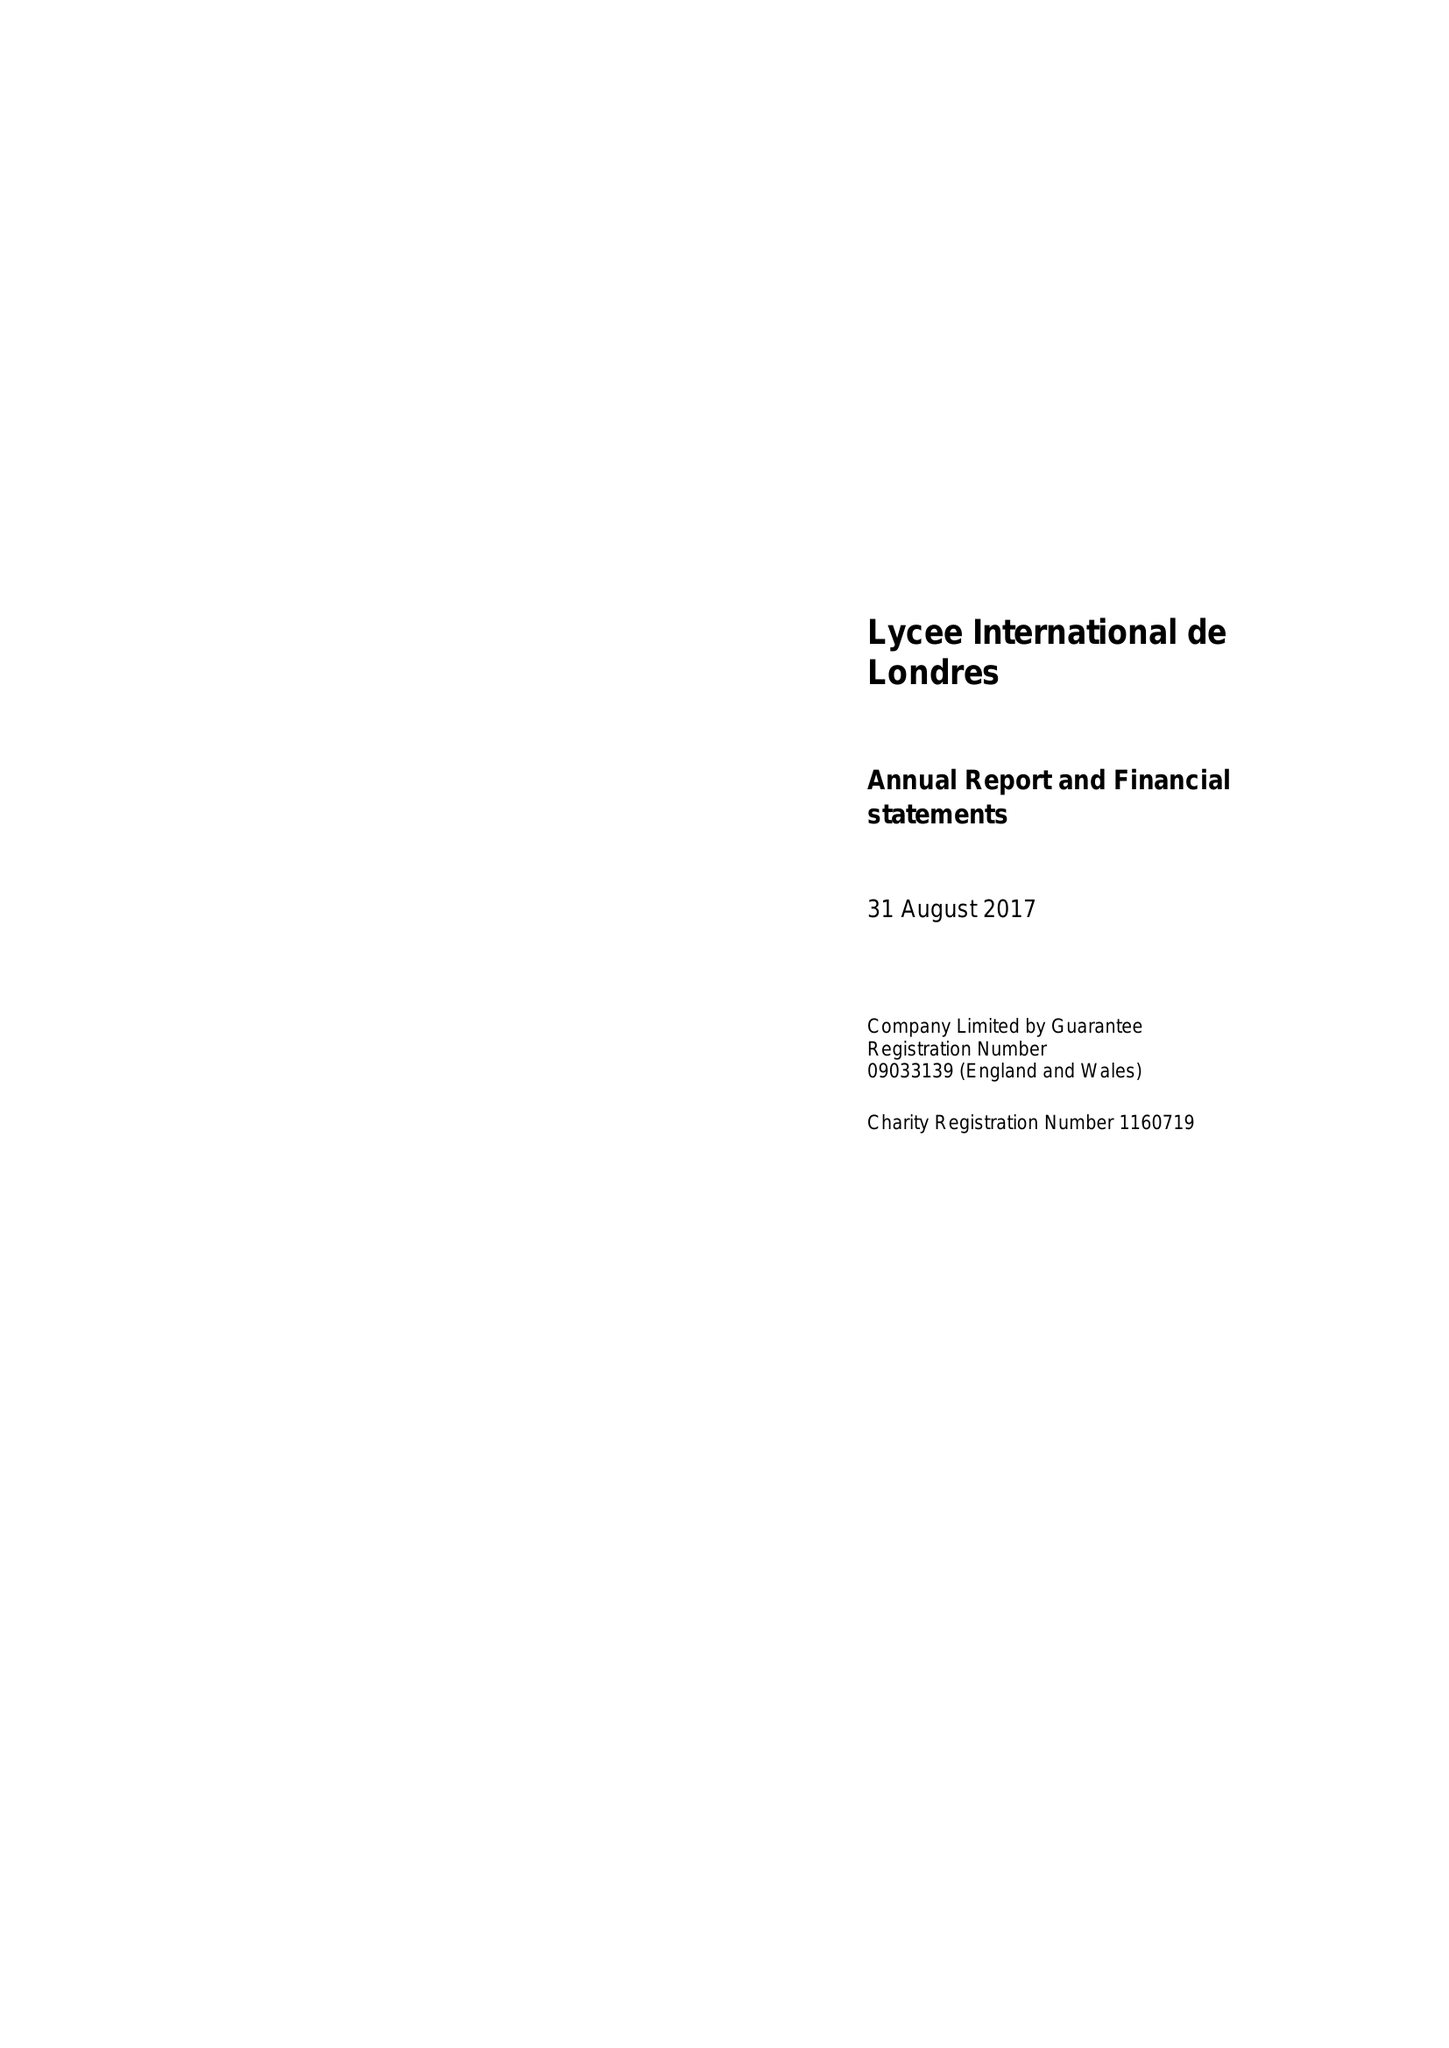What is the value for the address__post_town?
Answer the question using a single word or phrase. WEMBLEY 